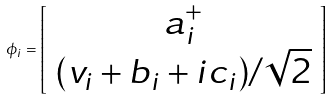<formula> <loc_0><loc_0><loc_500><loc_500>\phi _ { i } = \left [ \begin{array} { c } a _ { i } ^ { + } \\ ( v _ { i } + b _ { i } + i c _ { i } ) / \sqrt { 2 } \end{array} \right ]</formula> 